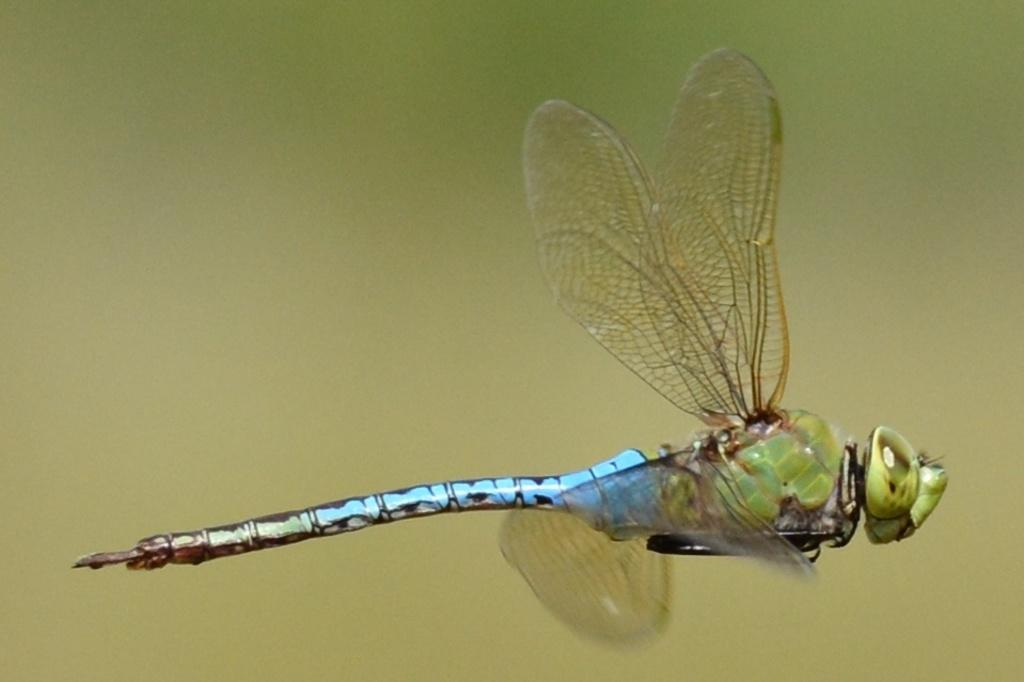What type of insect is in the image? There is a dragonfly in the image. Where is the dragonfly located in the image? The dragonfly is in the air. Can you describe the background of the image? The background of the image is blurred. What type of pot is visible in the image? There is no pot present in the image; it features a dragonfly in the air. How is the milk being used in the image? There is no milk present in the image. 